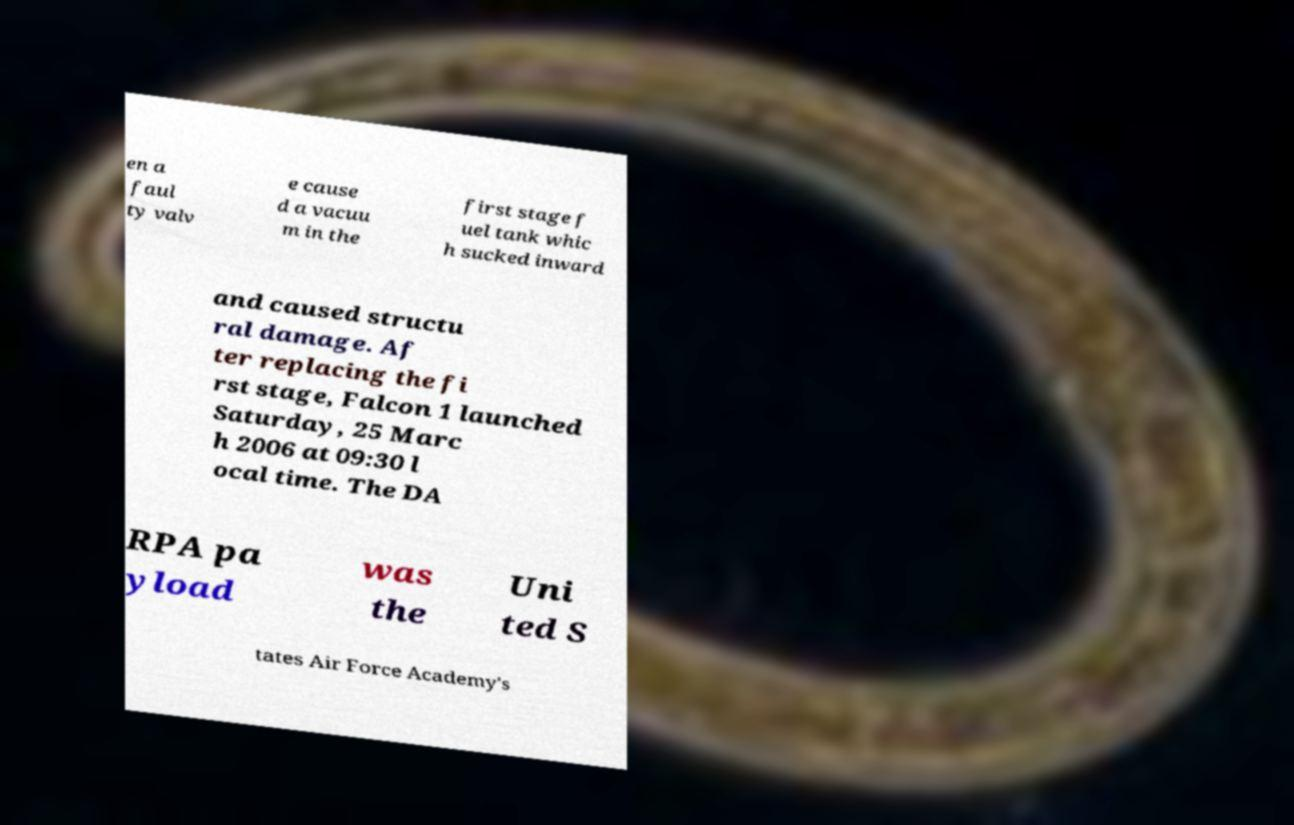What messages or text are displayed in this image? I need them in a readable, typed format. en a faul ty valv e cause d a vacuu m in the first stage f uel tank whic h sucked inward and caused structu ral damage. Af ter replacing the fi rst stage, Falcon 1 launched Saturday, 25 Marc h 2006 at 09:30 l ocal time. The DA RPA pa yload was the Uni ted S tates Air Force Academy's 